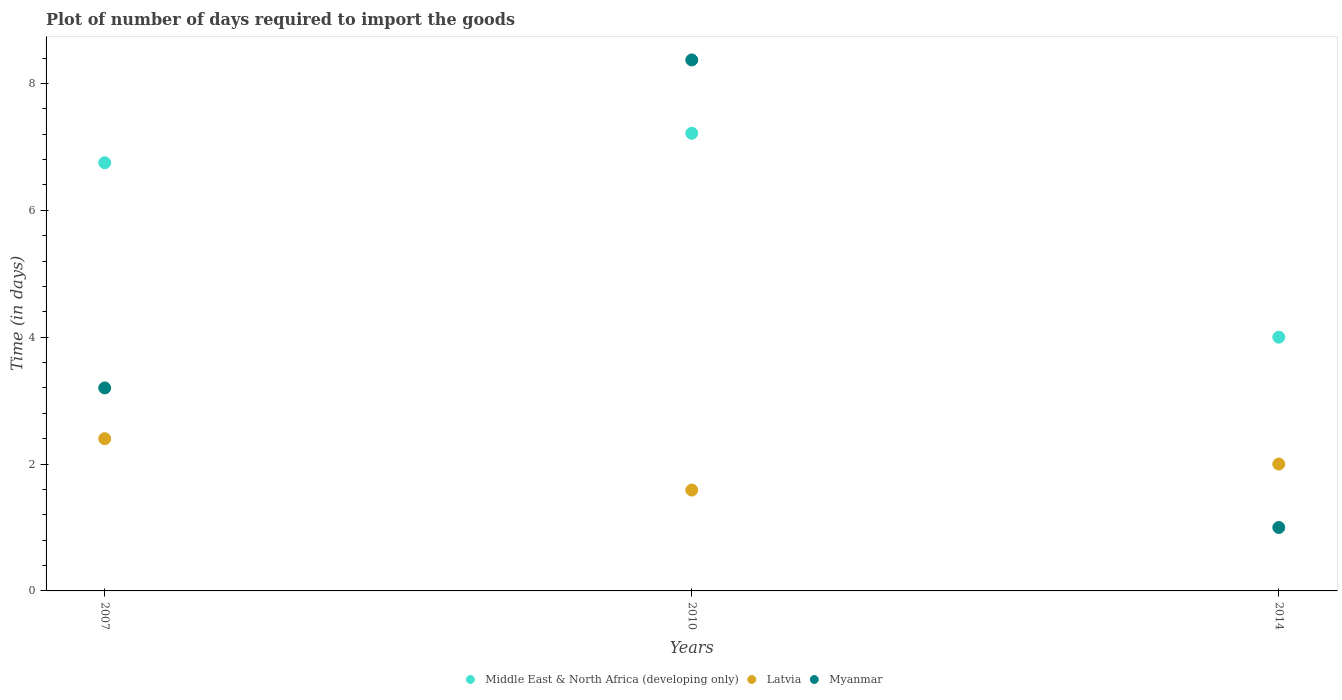What is the time required to import goods in Middle East & North Africa (developing only) in 2010?
Your response must be concise. 7.21. Across all years, what is the maximum time required to import goods in Middle East & North Africa (developing only)?
Provide a short and direct response. 7.21. What is the total time required to import goods in Myanmar in the graph?
Give a very brief answer. 12.57. What is the difference between the time required to import goods in Myanmar in 2007 and that in 2010?
Ensure brevity in your answer.  -5.17. What is the difference between the time required to import goods in Myanmar in 2007 and the time required to import goods in Latvia in 2010?
Your answer should be very brief. 1.61. What is the average time required to import goods in Middle East & North Africa (developing only) per year?
Your answer should be compact. 5.99. In the year 2007, what is the difference between the time required to import goods in Myanmar and time required to import goods in Latvia?
Offer a terse response. 0.8. What is the ratio of the time required to import goods in Middle East & North Africa (developing only) in 2007 to that in 2010?
Make the answer very short. 0.94. Is the difference between the time required to import goods in Myanmar in 2010 and 2014 greater than the difference between the time required to import goods in Latvia in 2010 and 2014?
Make the answer very short. Yes. What is the difference between the highest and the second highest time required to import goods in Middle East & North Africa (developing only)?
Provide a short and direct response. 0.46. What is the difference between the highest and the lowest time required to import goods in Latvia?
Ensure brevity in your answer.  0.81. Is the sum of the time required to import goods in Myanmar in 2007 and 2010 greater than the maximum time required to import goods in Middle East & North Africa (developing only) across all years?
Provide a short and direct response. Yes. Is it the case that in every year, the sum of the time required to import goods in Latvia and time required to import goods in Middle East & North Africa (developing only)  is greater than the time required to import goods in Myanmar?
Provide a succinct answer. Yes. Is the time required to import goods in Myanmar strictly less than the time required to import goods in Middle East & North Africa (developing only) over the years?
Give a very brief answer. No. How many dotlines are there?
Provide a succinct answer. 3. What is the difference between two consecutive major ticks on the Y-axis?
Your answer should be very brief. 2. Are the values on the major ticks of Y-axis written in scientific E-notation?
Your answer should be compact. No. Does the graph contain any zero values?
Your answer should be very brief. No. Does the graph contain grids?
Provide a succinct answer. No. What is the title of the graph?
Your response must be concise. Plot of number of days required to import the goods. Does "Gabon" appear as one of the legend labels in the graph?
Make the answer very short. No. What is the label or title of the Y-axis?
Your answer should be very brief. Time (in days). What is the Time (in days) in Middle East & North Africa (developing only) in 2007?
Offer a terse response. 6.75. What is the Time (in days) of Myanmar in 2007?
Your answer should be compact. 3.2. What is the Time (in days) in Middle East & North Africa (developing only) in 2010?
Your response must be concise. 7.21. What is the Time (in days) in Latvia in 2010?
Keep it short and to the point. 1.59. What is the Time (in days) in Myanmar in 2010?
Your answer should be very brief. 8.37. What is the Time (in days) of Latvia in 2014?
Your response must be concise. 2. Across all years, what is the maximum Time (in days) of Middle East & North Africa (developing only)?
Your answer should be compact. 7.21. Across all years, what is the maximum Time (in days) in Myanmar?
Offer a very short reply. 8.37. Across all years, what is the minimum Time (in days) of Latvia?
Provide a succinct answer. 1.59. Across all years, what is the minimum Time (in days) in Myanmar?
Give a very brief answer. 1. What is the total Time (in days) in Middle East & North Africa (developing only) in the graph?
Give a very brief answer. 17.96. What is the total Time (in days) of Latvia in the graph?
Provide a short and direct response. 5.99. What is the total Time (in days) of Myanmar in the graph?
Provide a succinct answer. 12.57. What is the difference between the Time (in days) of Middle East & North Africa (developing only) in 2007 and that in 2010?
Offer a terse response. -0.46. What is the difference between the Time (in days) of Latvia in 2007 and that in 2010?
Keep it short and to the point. 0.81. What is the difference between the Time (in days) of Myanmar in 2007 and that in 2010?
Your answer should be very brief. -5.17. What is the difference between the Time (in days) in Middle East & North Africa (developing only) in 2007 and that in 2014?
Ensure brevity in your answer.  2.75. What is the difference between the Time (in days) in Latvia in 2007 and that in 2014?
Offer a very short reply. 0.4. What is the difference between the Time (in days) of Myanmar in 2007 and that in 2014?
Ensure brevity in your answer.  2.2. What is the difference between the Time (in days) in Middle East & North Africa (developing only) in 2010 and that in 2014?
Offer a terse response. 3.21. What is the difference between the Time (in days) in Latvia in 2010 and that in 2014?
Give a very brief answer. -0.41. What is the difference between the Time (in days) of Myanmar in 2010 and that in 2014?
Provide a short and direct response. 7.37. What is the difference between the Time (in days) of Middle East & North Africa (developing only) in 2007 and the Time (in days) of Latvia in 2010?
Your answer should be very brief. 5.16. What is the difference between the Time (in days) of Middle East & North Africa (developing only) in 2007 and the Time (in days) of Myanmar in 2010?
Give a very brief answer. -1.62. What is the difference between the Time (in days) of Latvia in 2007 and the Time (in days) of Myanmar in 2010?
Provide a short and direct response. -5.97. What is the difference between the Time (in days) of Middle East & North Africa (developing only) in 2007 and the Time (in days) of Latvia in 2014?
Give a very brief answer. 4.75. What is the difference between the Time (in days) in Middle East & North Africa (developing only) in 2007 and the Time (in days) in Myanmar in 2014?
Provide a short and direct response. 5.75. What is the difference between the Time (in days) of Latvia in 2007 and the Time (in days) of Myanmar in 2014?
Your answer should be compact. 1.4. What is the difference between the Time (in days) in Middle East & North Africa (developing only) in 2010 and the Time (in days) in Latvia in 2014?
Make the answer very short. 5.21. What is the difference between the Time (in days) of Middle East & North Africa (developing only) in 2010 and the Time (in days) of Myanmar in 2014?
Your response must be concise. 6.21. What is the difference between the Time (in days) of Latvia in 2010 and the Time (in days) of Myanmar in 2014?
Ensure brevity in your answer.  0.59. What is the average Time (in days) of Middle East & North Africa (developing only) per year?
Provide a short and direct response. 5.99. What is the average Time (in days) of Latvia per year?
Offer a very short reply. 2. What is the average Time (in days) of Myanmar per year?
Your answer should be compact. 4.19. In the year 2007, what is the difference between the Time (in days) in Middle East & North Africa (developing only) and Time (in days) in Latvia?
Offer a terse response. 4.35. In the year 2007, what is the difference between the Time (in days) of Middle East & North Africa (developing only) and Time (in days) of Myanmar?
Offer a terse response. 3.55. In the year 2007, what is the difference between the Time (in days) of Latvia and Time (in days) of Myanmar?
Your answer should be very brief. -0.8. In the year 2010, what is the difference between the Time (in days) of Middle East & North Africa (developing only) and Time (in days) of Latvia?
Offer a terse response. 5.62. In the year 2010, what is the difference between the Time (in days) of Middle East & North Africa (developing only) and Time (in days) of Myanmar?
Keep it short and to the point. -1.16. In the year 2010, what is the difference between the Time (in days) of Latvia and Time (in days) of Myanmar?
Your answer should be compact. -6.78. What is the ratio of the Time (in days) in Middle East & North Africa (developing only) in 2007 to that in 2010?
Make the answer very short. 0.94. What is the ratio of the Time (in days) in Latvia in 2007 to that in 2010?
Provide a succinct answer. 1.51. What is the ratio of the Time (in days) of Myanmar in 2007 to that in 2010?
Make the answer very short. 0.38. What is the ratio of the Time (in days) in Middle East & North Africa (developing only) in 2007 to that in 2014?
Make the answer very short. 1.69. What is the ratio of the Time (in days) in Latvia in 2007 to that in 2014?
Your answer should be compact. 1.2. What is the ratio of the Time (in days) of Middle East & North Africa (developing only) in 2010 to that in 2014?
Provide a succinct answer. 1.8. What is the ratio of the Time (in days) in Latvia in 2010 to that in 2014?
Keep it short and to the point. 0.8. What is the ratio of the Time (in days) of Myanmar in 2010 to that in 2014?
Provide a short and direct response. 8.37. What is the difference between the highest and the second highest Time (in days) in Middle East & North Africa (developing only)?
Provide a succinct answer. 0.46. What is the difference between the highest and the second highest Time (in days) of Myanmar?
Your response must be concise. 5.17. What is the difference between the highest and the lowest Time (in days) of Middle East & North Africa (developing only)?
Provide a succinct answer. 3.21. What is the difference between the highest and the lowest Time (in days) of Latvia?
Ensure brevity in your answer.  0.81. What is the difference between the highest and the lowest Time (in days) of Myanmar?
Your answer should be compact. 7.37. 